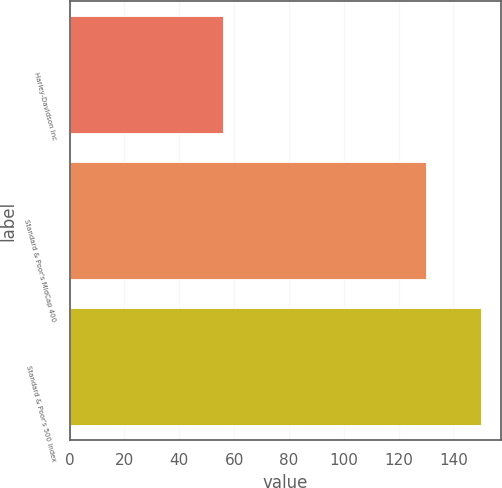<chart> <loc_0><loc_0><loc_500><loc_500><bar_chart><fcel>Harley-Davidson Inc<fcel>Standard & Poor's MidCap 400<fcel>Standard & Poor's 500 Index<nl><fcel>56<fcel>130<fcel>150<nl></chart> 